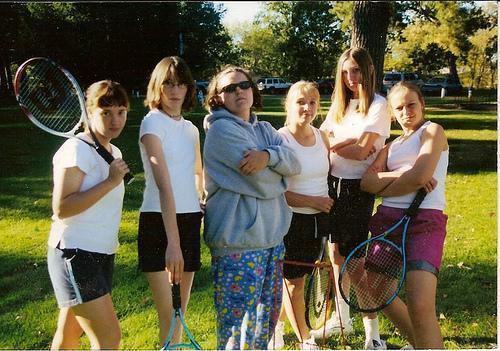How many women are in the group?
Give a very brief answer. 6. How many tennis rackets are there?
Give a very brief answer. 3. How many people are in the picture?
Give a very brief answer. 6. How many bowls in the image contain broccoli?
Give a very brief answer. 0. 